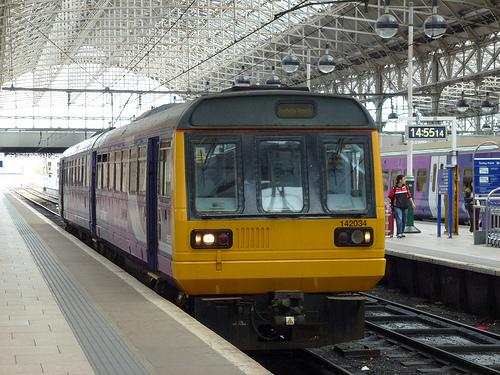Question: what numbers are printed on the train?
Choices:
A. 145034.
B. 142134.
C. 142034.
D. 143033.
Answer with the letter. Answer: C Question: how many people are on the platform?
Choices:
A. 12.
B. 2.
C. 13.
D. 5.
Answer with the letter. Answer: B Question: who has a red suitcase?
Choices:
A. The passenger.
B. The man in line.
C. The man with the red white and black shirt.
D. The person in the striped shirt.
Answer with the letter. Answer: C 